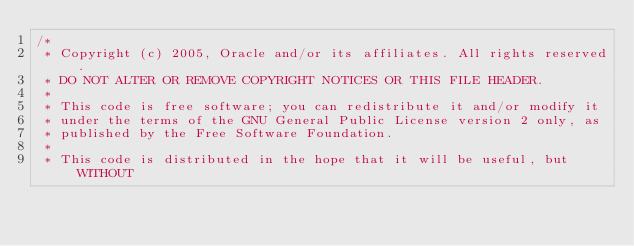<code> <loc_0><loc_0><loc_500><loc_500><_Java_>/*
 * Copyright (c) 2005, Oracle and/or its affiliates. All rights reserved.
 * DO NOT ALTER OR REMOVE COPYRIGHT NOTICES OR THIS FILE HEADER.
 *
 * This code is free software; you can redistribute it and/or modify it
 * under the terms of the GNU General Public License version 2 only, as
 * published by the Free Software Foundation.
 *
 * This code is distributed in the hope that it will be useful, but WITHOUT</code> 